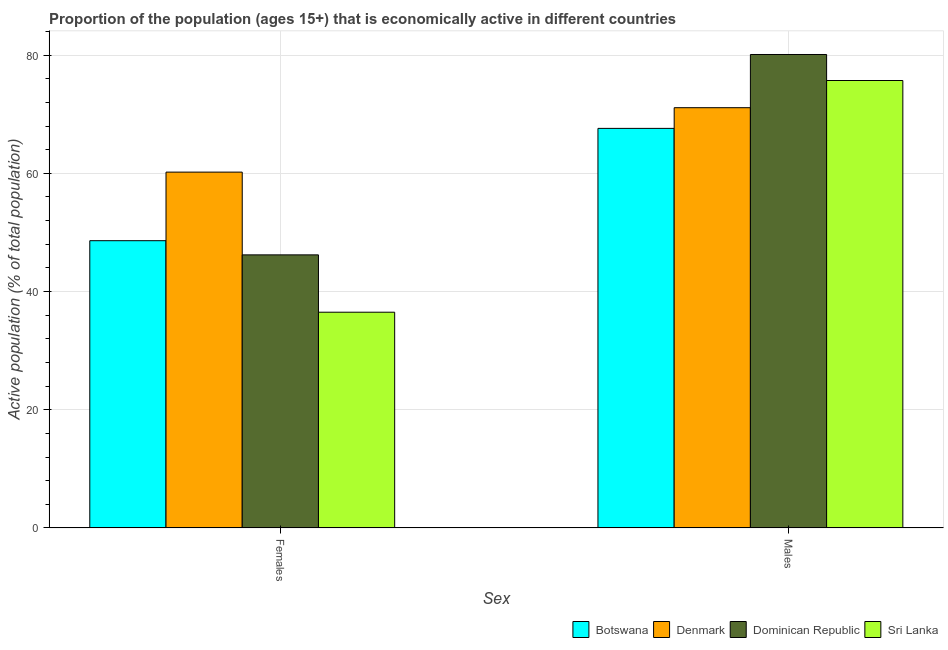How many different coloured bars are there?
Ensure brevity in your answer.  4. Are the number of bars on each tick of the X-axis equal?
Make the answer very short. Yes. How many bars are there on the 2nd tick from the left?
Ensure brevity in your answer.  4. How many bars are there on the 2nd tick from the right?
Offer a very short reply. 4. What is the label of the 2nd group of bars from the left?
Provide a succinct answer. Males. What is the percentage of economically active female population in Denmark?
Your answer should be compact. 60.2. Across all countries, what is the maximum percentage of economically active female population?
Keep it short and to the point. 60.2. Across all countries, what is the minimum percentage of economically active male population?
Your response must be concise. 67.6. In which country was the percentage of economically active male population minimum?
Your answer should be compact. Botswana. What is the total percentage of economically active female population in the graph?
Make the answer very short. 191.5. What is the difference between the percentage of economically active male population in Dominican Republic and that in Botswana?
Ensure brevity in your answer.  12.5. What is the difference between the percentage of economically active male population in Botswana and the percentage of economically active female population in Denmark?
Offer a very short reply. 7.4. What is the average percentage of economically active male population per country?
Provide a short and direct response. 73.62. What is the difference between the percentage of economically active female population and percentage of economically active male population in Botswana?
Ensure brevity in your answer.  -19. What is the ratio of the percentage of economically active male population in Denmark to that in Sri Lanka?
Provide a succinct answer. 0.94. Is the percentage of economically active female population in Botswana less than that in Sri Lanka?
Ensure brevity in your answer.  No. In how many countries, is the percentage of economically active female population greater than the average percentage of economically active female population taken over all countries?
Offer a very short reply. 2. What does the 1st bar from the left in Females represents?
Offer a very short reply. Botswana. What does the 1st bar from the right in Females represents?
Your answer should be very brief. Sri Lanka. How many bars are there?
Your answer should be very brief. 8. Does the graph contain any zero values?
Your answer should be very brief. No. Does the graph contain grids?
Your answer should be very brief. Yes. Where does the legend appear in the graph?
Offer a very short reply. Bottom right. How are the legend labels stacked?
Offer a very short reply. Horizontal. What is the title of the graph?
Offer a very short reply. Proportion of the population (ages 15+) that is economically active in different countries. What is the label or title of the X-axis?
Offer a very short reply. Sex. What is the label or title of the Y-axis?
Your response must be concise. Active population (% of total population). What is the Active population (% of total population) of Botswana in Females?
Give a very brief answer. 48.6. What is the Active population (% of total population) in Denmark in Females?
Make the answer very short. 60.2. What is the Active population (% of total population) of Dominican Republic in Females?
Make the answer very short. 46.2. What is the Active population (% of total population) of Sri Lanka in Females?
Offer a very short reply. 36.5. What is the Active population (% of total population) in Botswana in Males?
Give a very brief answer. 67.6. What is the Active population (% of total population) of Denmark in Males?
Give a very brief answer. 71.1. What is the Active population (% of total population) of Dominican Republic in Males?
Your answer should be very brief. 80.1. What is the Active population (% of total population) of Sri Lanka in Males?
Offer a terse response. 75.7. Across all Sex, what is the maximum Active population (% of total population) of Botswana?
Give a very brief answer. 67.6. Across all Sex, what is the maximum Active population (% of total population) in Denmark?
Offer a very short reply. 71.1. Across all Sex, what is the maximum Active population (% of total population) in Dominican Republic?
Make the answer very short. 80.1. Across all Sex, what is the maximum Active population (% of total population) in Sri Lanka?
Make the answer very short. 75.7. Across all Sex, what is the minimum Active population (% of total population) of Botswana?
Your answer should be compact. 48.6. Across all Sex, what is the minimum Active population (% of total population) of Denmark?
Your response must be concise. 60.2. Across all Sex, what is the minimum Active population (% of total population) in Dominican Republic?
Provide a short and direct response. 46.2. Across all Sex, what is the minimum Active population (% of total population) in Sri Lanka?
Provide a short and direct response. 36.5. What is the total Active population (% of total population) in Botswana in the graph?
Your answer should be very brief. 116.2. What is the total Active population (% of total population) of Denmark in the graph?
Offer a terse response. 131.3. What is the total Active population (% of total population) in Dominican Republic in the graph?
Ensure brevity in your answer.  126.3. What is the total Active population (% of total population) in Sri Lanka in the graph?
Provide a short and direct response. 112.2. What is the difference between the Active population (% of total population) of Botswana in Females and that in Males?
Keep it short and to the point. -19. What is the difference between the Active population (% of total population) of Dominican Republic in Females and that in Males?
Ensure brevity in your answer.  -33.9. What is the difference between the Active population (% of total population) of Sri Lanka in Females and that in Males?
Make the answer very short. -39.2. What is the difference between the Active population (% of total population) in Botswana in Females and the Active population (% of total population) in Denmark in Males?
Offer a terse response. -22.5. What is the difference between the Active population (% of total population) in Botswana in Females and the Active population (% of total population) in Dominican Republic in Males?
Offer a terse response. -31.5. What is the difference between the Active population (% of total population) of Botswana in Females and the Active population (% of total population) of Sri Lanka in Males?
Keep it short and to the point. -27.1. What is the difference between the Active population (% of total population) in Denmark in Females and the Active population (% of total population) in Dominican Republic in Males?
Keep it short and to the point. -19.9. What is the difference between the Active population (% of total population) in Denmark in Females and the Active population (% of total population) in Sri Lanka in Males?
Offer a terse response. -15.5. What is the difference between the Active population (% of total population) of Dominican Republic in Females and the Active population (% of total population) of Sri Lanka in Males?
Offer a terse response. -29.5. What is the average Active population (% of total population) in Botswana per Sex?
Offer a very short reply. 58.1. What is the average Active population (% of total population) in Denmark per Sex?
Your answer should be compact. 65.65. What is the average Active population (% of total population) of Dominican Republic per Sex?
Keep it short and to the point. 63.15. What is the average Active population (% of total population) in Sri Lanka per Sex?
Provide a short and direct response. 56.1. What is the difference between the Active population (% of total population) in Denmark and Active population (% of total population) in Sri Lanka in Females?
Offer a terse response. 23.7. What is the difference between the Active population (% of total population) in Botswana and Active population (% of total population) in Denmark in Males?
Provide a succinct answer. -3.5. What is the difference between the Active population (% of total population) of Botswana and Active population (% of total population) of Dominican Republic in Males?
Give a very brief answer. -12.5. What is the difference between the Active population (% of total population) in Denmark and Active population (% of total population) in Dominican Republic in Males?
Your answer should be compact. -9. What is the difference between the Active population (% of total population) of Denmark and Active population (% of total population) of Sri Lanka in Males?
Offer a very short reply. -4.6. What is the ratio of the Active population (% of total population) in Botswana in Females to that in Males?
Keep it short and to the point. 0.72. What is the ratio of the Active population (% of total population) of Denmark in Females to that in Males?
Make the answer very short. 0.85. What is the ratio of the Active population (% of total population) in Dominican Republic in Females to that in Males?
Make the answer very short. 0.58. What is the ratio of the Active population (% of total population) in Sri Lanka in Females to that in Males?
Offer a very short reply. 0.48. What is the difference between the highest and the second highest Active population (% of total population) in Dominican Republic?
Provide a succinct answer. 33.9. What is the difference between the highest and the second highest Active population (% of total population) of Sri Lanka?
Provide a succinct answer. 39.2. What is the difference between the highest and the lowest Active population (% of total population) in Botswana?
Your answer should be compact. 19. What is the difference between the highest and the lowest Active population (% of total population) in Denmark?
Give a very brief answer. 10.9. What is the difference between the highest and the lowest Active population (% of total population) in Dominican Republic?
Give a very brief answer. 33.9. What is the difference between the highest and the lowest Active population (% of total population) in Sri Lanka?
Provide a succinct answer. 39.2. 